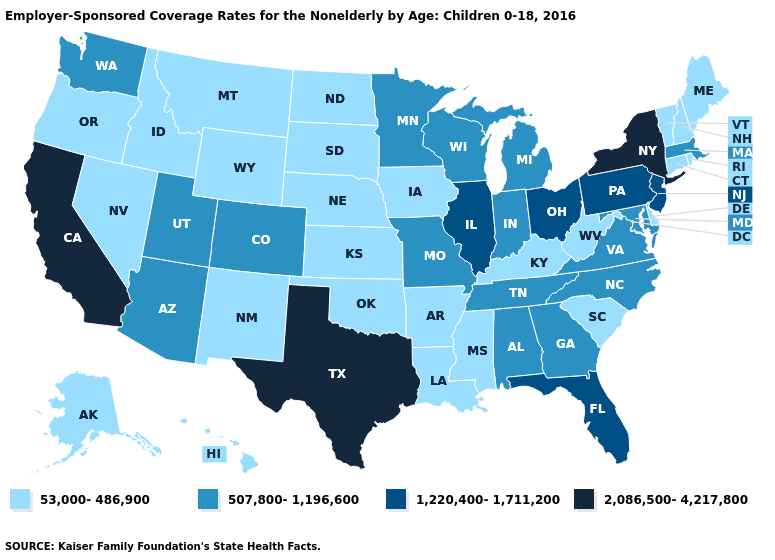Which states have the highest value in the USA?
Write a very short answer. California, New York, Texas. Does Ohio have a lower value than Texas?
Short answer required. Yes. Among the states that border New Jersey , does Delaware have the lowest value?
Keep it brief. Yes. What is the value of Virginia?
Keep it brief. 507,800-1,196,600. What is the value of Wisconsin?
Write a very short answer. 507,800-1,196,600. Name the states that have a value in the range 2,086,500-4,217,800?
Keep it brief. California, New York, Texas. Name the states that have a value in the range 1,220,400-1,711,200?
Keep it brief. Florida, Illinois, New Jersey, Ohio, Pennsylvania. Name the states that have a value in the range 507,800-1,196,600?
Quick response, please. Alabama, Arizona, Colorado, Georgia, Indiana, Maryland, Massachusetts, Michigan, Minnesota, Missouri, North Carolina, Tennessee, Utah, Virginia, Washington, Wisconsin. Does California have a lower value than Rhode Island?
Quick response, please. No. Name the states that have a value in the range 53,000-486,900?
Answer briefly. Alaska, Arkansas, Connecticut, Delaware, Hawaii, Idaho, Iowa, Kansas, Kentucky, Louisiana, Maine, Mississippi, Montana, Nebraska, Nevada, New Hampshire, New Mexico, North Dakota, Oklahoma, Oregon, Rhode Island, South Carolina, South Dakota, Vermont, West Virginia, Wyoming. Name the states that have a value in the range 53,000-486,900?
Be succinct. Alaska, Arkansas, Connecticut, Delaware, Hawaii, Idaho, Iowa, Kansas, Kentucky, Louisiana, Maine, Mississippi, Montana, Nebraska, Nevada, New Hampshire, New Mexico, North Dakota, Oklahoma, Oregon, Rhode Island, South Carolina, South Dakota, Vermont, West Virginia, Wyoming. Does New Jersey have the lowest value in the USA?
Short answer required. No. Among the states that border Louisiana , which have the lowest value?
Concise answer only. Arkansas, Mississippi. Does Georgia have a higher value than South Dakota?
Quick response, please. Yes. Which states have the lowest value in the West?
Be succinct. Alaska, Hawaii, Idaho, Montana, Nevada, New Mexico, Oregon, Wyoming. 